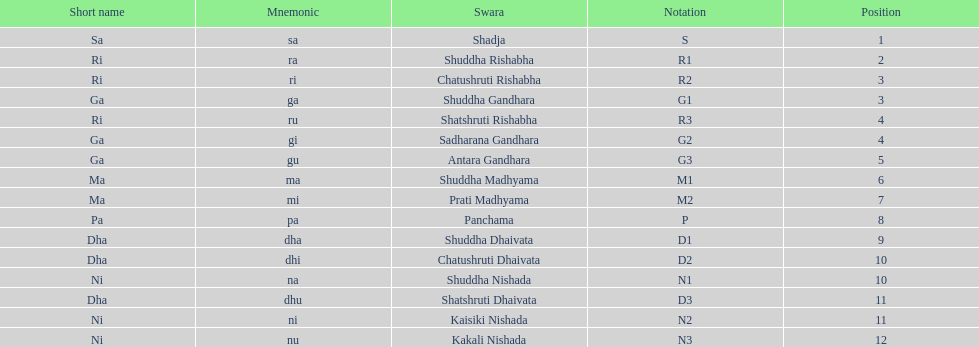Which swara holds the last position? Kakali Nishada. 